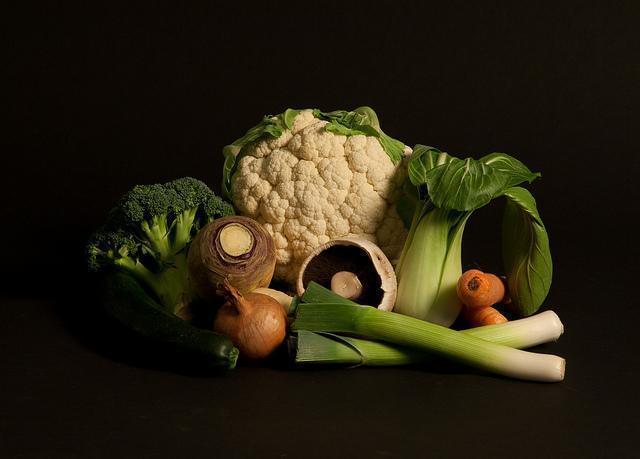Where can these foods be found?
Choose the right answer and clarify with the format: 'Answer: answer
Rationale: rationale.'
Options: Fast food, bar, garden, office. Answer: garden.
Rationale: Vegetables are typically grown in a garden. 